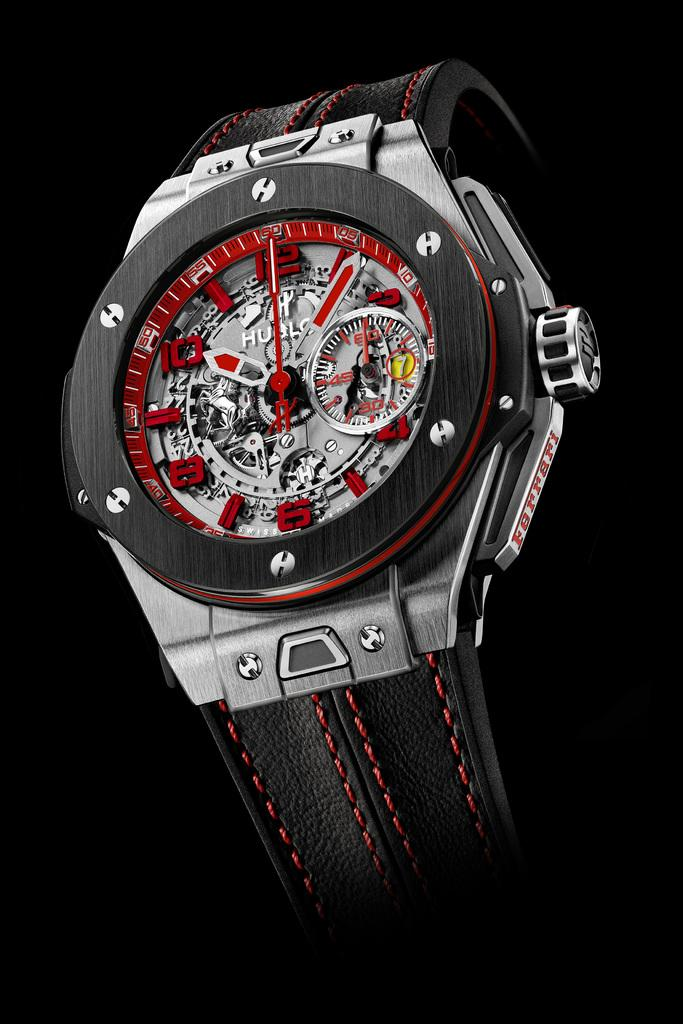<image>
Create a compact narrative representing the image presented. A watch that is black and silver with red markings and has the letters HUGLO on the watch face. 